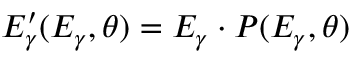Convert formula to latex. <formula><loc_0><loc_0><loc_500><loc_500>E _ { \gamma } ^ { \prime } ( E _ { \gamma } , \theta ) = E _ { \gamma } \cdot P ( E _ { \gamma } , \theta )</formula> 